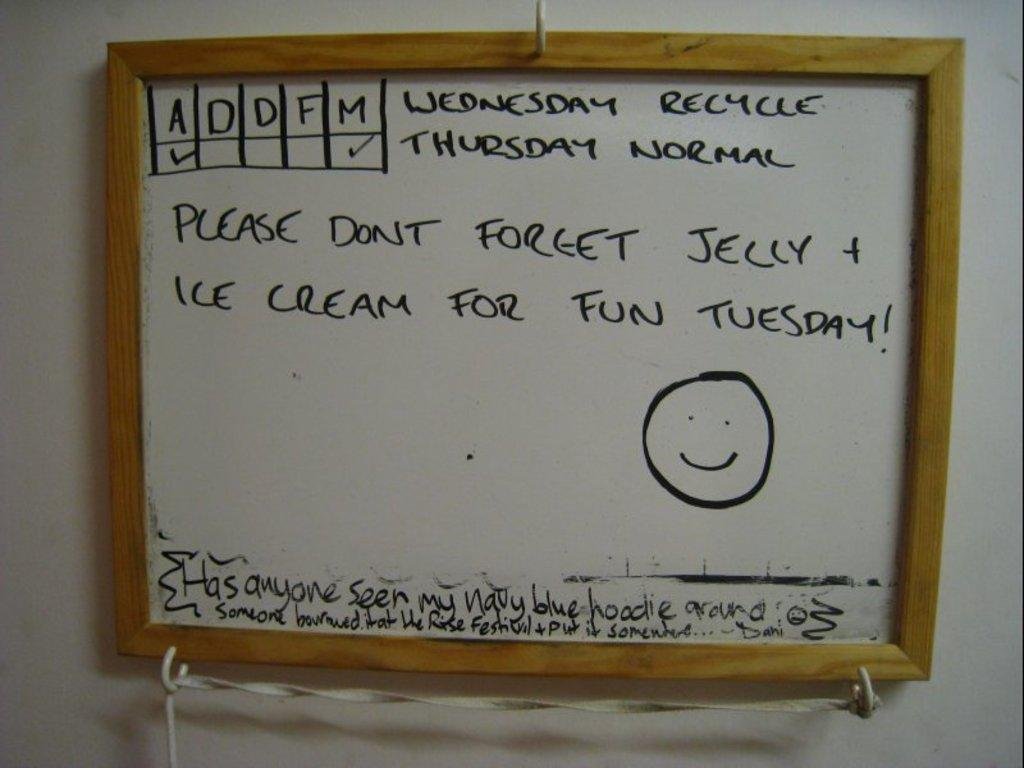What is attached to the wall in the image? There is a frame attached to the wall in the image. What can be found on the frame? There is text written on the frame. What type of loaf is visible in the image? There is no loaf present in the image. How does the fog affect the visibility of the text on the frame? There is no fog present in the image, so it does not affect the visibility of the text on the frame. 